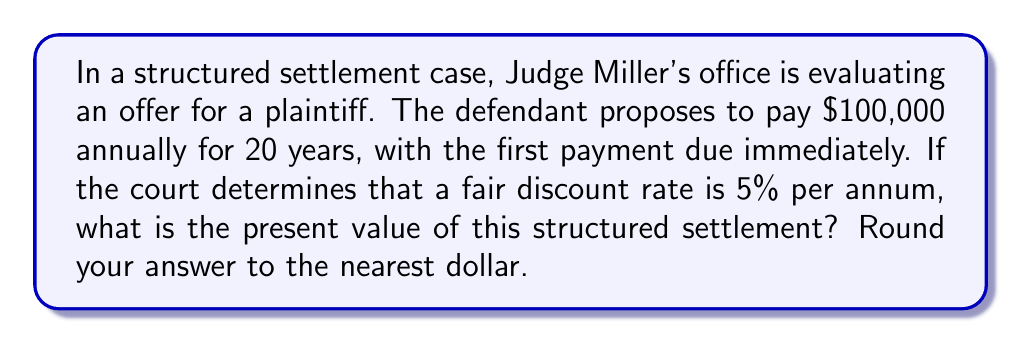Show me your answer to this math problem. To solve this problem, we need to calculate the present value of an annuity with the following parameters:

- Annual payment (A) = $100,000
- Number of payments (n) = 20
- Discount rate (r) = 5% = 0.05
- Payments occur at the beginning of each period (annuity due)

The formula for the present value of an annuity due is:

$$ PV = A \cdot \frac{1 - (1 + r)^{-n}}{r} \cdot (1 + r) $$

Let's break down the calculation step-by-step:

1) First, calculate the term inside the parentheses:
   $$ (1 + 0.05)^{-20} = 0.3768 $$

2) Now, calculate the fraction term:
   $$ \frac{1 - 0.3768}{0.05} = 12.4640 $$

3) Multiply by (1 + r):
   $$ 12.4640 \cdot (1 + 0.05) = 13.0872 $$

4) Finally, multiply by the annual payment:
   $$ 100,000 \cdot 13.0872 = 1,308,720 $$

Therefore, the present value of the structured settlement is $1,308,720.
Answer: $1,308,720 